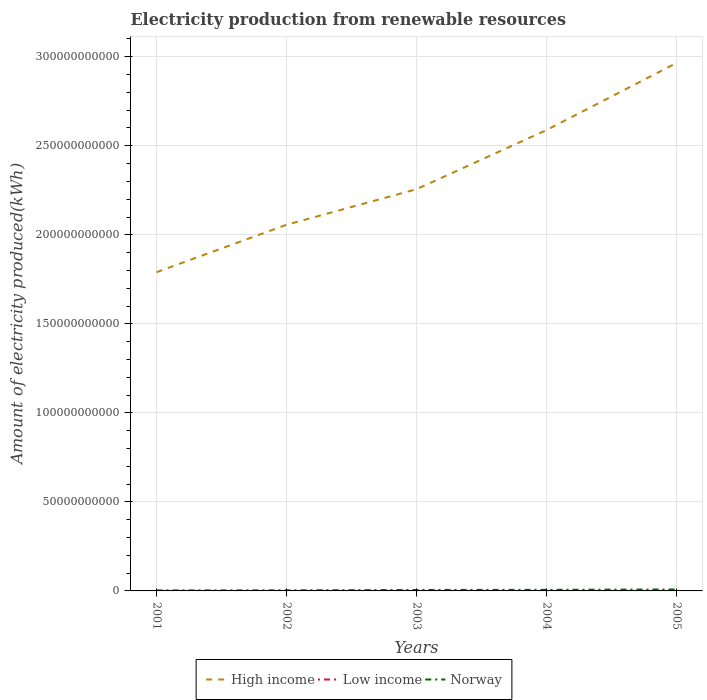Does the line corresponding to High income intersect with the line corresponding to Low income?
Make the answer very short. No. Is the number of lines equal to the number of legend labels?
Your answer should be very brief. Yes. Across all years, what is the maximum amount of electricity produced in Norway?
Provide a succinct answer. 2.82e+08. What is the total amount of electricity produced in High income in the graph?
Keep it short and to the point. -3.32e+1. What is the difference between the highest and the second highest amount of electricity produced in High income?
Your response must be concise. 1.17e+11. What is the difference between the highest and the lowest amount of electricity produced in Low income?
Offer a very short reply. 3. Is the amount of electricity produced in High income strictly greater than the amount of electricity produced in Norway over the years?
Your answer should be very brief. No. How many years are there in the graph?
Give a very brief answer. 5. Are the values on the major ticks of Y-axis written in scientific E-notation?
Provide a short and direct response. No. Does the graph contain any zero values?
Your answer should be very brief. No. How are the legend labels stacked?
Your answer should be very brief. Horizontal. What is the title of the graph?
Your answer should be very brief. Electricity production from renewable resources. What is the label or title of the Y-axis?
Your response must be concise. Amount of electricity produced(kWh). What is the Amount of electricity produced(kWh) of High income in 2001?
Give a very brief answer. 1.79e+11. What is the Amount of electricity produced(kWh) in Norway in 2001?
Keep it short and to the point. 2.82e+08. What is the Amount of electricity produced(kWh) in High income in 2002?
Offer a terse response. 2.06e+11. What is the Amount of electricity produced(kWh) of Low income in 2002?
Your answer should be very brief. 3.00e+06. What is the Amount of electricity produced(kWh) of Norway in 2002?
Provide a short and direct response. 3.25e+08. What is the Amount of electricity produced(kWh) of High income in 2003?
Keep it short and to the point. 2.26e+11. What is the Amount of electricity produced(kWh) of Low income in 2003?
Offer a terse response. 1.10e+07. What is the Amount of electricity produced(kWh) of Norway in 2003?
Provide a short and direct response. 5.48e+08. What is the Amount of electricity produced(kWh) of High income in 2004?
Offer a terse response. 2.59e+11. What is the Amount of electricity produced(kWh) in Low income in 2004?
Offer a very short reply. 1.70e+07. What is the Amount of electricity produced(kWh) in Norway in 2004?
Provide a short and direct response. 6.11e+08. What is the Amount of electricity produced(kWh) of High income in 2005?
Offer a very short reply. 2.97e+11. What is the Amount of electricity produced(kWh) of Low income in 2005?
Your response must be concise. 1.80e+07. What is the Amount of electricity produced(kWh) in Norway in 2005?
Give a very brief answer. 8.32e+08. Across all years, what is the maximum Amount of electricity produced(kWh) in High income?
Make the answer very short. 2.97e+11. Across all years, what is the maximum Amount of electricity produced(kWh) of Low income?
Offer a very short reply. 1.80e+07. Across all years, what is the maximum Amount of electricity produced(kWh) of Norway?
Provide a short and direct response. 8.32e+08. Across all years, what is the minimum Amount of electricity produced(kWh) of High income?
Provide a succinct answer. 1.79e+11. Across all years, what is the minimum Amount of electricity produced(kWh) of Low income?
Offer a terse response. 3.00e+06. Across all years, what is the minimum Amount of electricity produced(kWh) in Norway?
Provide a succinct answer. 2.82e+08. What is the total Amount of electricity produced(kWh) of High income in the graph?
Ensure brevity in your answer.  1.17e+12. What is the total Amount of electricity produced(kWh) of Low income in the graph?
Provide a succinct answer. 5.30e+07. What is the total Amount of electricity produced(kWh) of Norway in the graph?
Provide a succinct answer. 2.60e+09. What is the difference between the Amount of electricity produced(kWh) in High income in 2001 and that in 2002?
Offer a very short reply. -2.66e+1. What is the difference between the Amount of electricity produced(kWh) in Low income in 2001 and that in 2002?
Make the answer very short. 1.00e+06. What is the difference between the Amount of electricity produced(kWh) of Norway in 2001 and that in 2002?
Ensure brevity in your answer.  -4.30e+07. What is the difference between the Amount of electricity produced(kWh) in High income in 2001 and that in 2003?
Keep it short and to the point. -4.66e+1. What is the difference between the Amount of electricity produced(kWh) of Low income in 2001 and that in 2003?
Make the answer very short. -7.00e+06. What is the difference between the Amount of electricity produced(kWh) in Norway in 2001 and that in 2003?
Your answer should be compact. -2.66e+08. What is the difference between the Amount of electricity produced(kWh) in High income in 2001 and that in 2004?
Give a very brief answer. -7.98e+1. What is the difference between the Amount of electricity produced(kWh) in Low income in 2001 and that in 2004?
Your answer should be compact. -1.30e+07. What is the difference between the Amount of electricity produced(kWh) in Norway in 2001 and that in 2004?
Give a very brief answer. -3.29e+08. What is the difference between the Amount of electricity produced(kWh) in High income in 2001 and that in 2005?
Offer a very short reply. -1.17e+11. What is the difference between the Amount of electricity produced(kWh) in Low income in 2001 and that in 2005?
Your answer should be very brief. -1.40e+07. What is the difference between the Amount of electricity produced(kWh) in Norway in 2001 and that in 2005?
Keep it short and to the point. -5.50e+08. What is the difference between the Amount of electricity produced(kWh) of High income in 2002 and that in 2003?
Your response must be concise. -2.00e+1. What is the difference between the Amount of electricity produced(kWh) in Low income in 2002 and that in 2003?
Your answer should be compact. -8.00e+06. What is the difference between the Amount of electricity produced(kWh) in Norway in 2002 and that in 2003?
Offer a terse response. -2.23e+08. What is the difference between the Amount of electricity produced(kWh) in High income in 2002 and that in 2004?
Your answer should be very brief. -5.32e+1. What is the difference between the Amount of electricity produced(kWh) in Low income in 2002 and that in 2004?
Keep it short and to the point. -1.40e+07. What is the difference between the Amount of electricity produced(kWh) of Norway in 2002 and that in 2004?
Make the answer very short. -2.86e+08. What is the difference between the Amount of electricity produced(kWh) in High income in 2002 and that in 2005?
Ensure brevity in your answer.  -9.09e+1. What is the difference between the Amount of electricity produced(kWh) in Low income in 2002 and that in 2005?
Your answer should be compact. -1.50e+07. What is the difference between the Amount of electricity produced(kWh) in Norway in 2002 and that in 2005?
Ensure brevity in your answer.  -5.07e+08. What is the difference between the Amount of electricity produced(kWh) in High income in 2003 and that in 2004?
Your answer should be compact. -3.32e+1. What is the difference between the Amount of electricity produced(kWh) in Low income in 2003 and that in 2004?
Your answer should be compact. -6.00e+06. What is the difference between the Amount of electricity produced(kWh) in Norway in 2003 and that in 2004?
Your answer should be compact. -6.30e+07. What is the difference between the Amount of electricity produced(kWh) of High income in 2003 and that in 2005?
Make the answer very short. -7.09e+1. What is the difference between the Amount of electricity produced(kWh) in Low income in 2003 and that in 2005?
Your answer should be compact. -7.00e+06. What is the difference between the Amount of electricity produced(kWh) of Norway in 2003 and that in 2005?
Make the answer very short. -2.84e+08. What is the difference between the Amount of electricity produced(kWh) in High income in 2004 and that in 2005?
Make the answer very short. -3.77e+1. What is the difference between the Amount of electricity produced(kWh) in Low income in 2004 and that in 2005?
Your response must be concise. -1.00e+06. What is the difference between the Amount of electricity produced(kWh) of Norway in 2004 and that in 2005?
Keep it short and to the point. -2.21e+08. What is the difference between the Amount of electricity produced(kWh) in High income in 2001 and the Amount of electricity produced(kWh) in Low income in 2002?
Your answer should be compact. 1.79e+11. What is the difference between the Amount of electricity produced(kWh) of High income in 2001 and the Amount of electricity produced(kWh) of Norway in 2002?
Your answer should be very brief. 1.79e+11. What is the difference between the Amount of electricity produced(kWh) in Low income in 2001 and the Amount of electricity produced(kWh) in Norway in 2002?
Provide a succinct answer. -3.21e+08. What is the difference between the Amount of electricity produced(kWh) of High income in 2001 and the Amount of electricity produced(kWh) of Low income in 2003?
Your response must be concise. 1.79e+11. What is the difference between the Amount of electricity produced(kWh) in High income in 2001 and the Amount of electricity produced(kWh) in Norway in 2003?
Give a very brief answer. 1.78e+11. What is the difference between the Amount of electricity produced(kWh) in Low income in 2001 and the Amount of electricity produced(kWh) in Norway in 2003?
Give a very brief answer. -5.44e+08. What is the difference between the Amount of electricity produced(kWh) in High income in 2001 and the Amount of electricity produced(kWh) in Low income in 2004?
Offer a terse response. 1.79e+11. What is the difference between the Amount of electricity produced(kWh) in High income in 2001 and the Amount of electricity produced(kWh) in Norway in 2004?
Offer a very short reply. 1.78e+11. What is the difference between the Amount of electricity produced(kWh) in Low income in 2001 and the Amount of electricity produced(kWh) in Norway in 2004?
Give a very brief answer. -6.07e+08. What is the difference between the Amount of electricity produced(kWh) of High income in 2001 and the Amount of electricity produced(kWh) of Low income in 2005?
Ensure brevity in your answer.  1.79e+11. What is the difference between the Amount of electricity produced(kWh) of High income in 2001 and the Amount of electricity produced(kWh) of Norway in 2005?
Your answer should be very brief. 1.78e+11. What is the difference between the Amount of electricity produced(kWh) in Low income in 2001 and the Amount of electricity produced(kWh) in Norway in 2005?
Offer a very short reply. -8.28e+08. What is the difference between the Amount of electricity produced(kWh) in High income in 2002 and the Amount of electricity produced(kWh) in Low income in 2003?
Provide a short and direct response. 2.06e+11. What is the difference between the Amount of electricity produced(kWh) in High income in 2002 and the Amount of electricity produced(kWh) in Norway in 2003?
Make the answer very short. 2.05e+11. What is the difference between the Amount of electricity produced(kWh) of Low income in 2002 and the Amount of electricity produced(kWh) of Norway in 2003?
Your answer should be very brief. -5.45e+08. What is the difference between the Amount of electricity produced(kWh) in High income in 2002 and the Amount of electricity produced(kWh) in Low income in 2004?
Your answer should be very brief. 2.06e+11. What is the difference between the Amount of electricity produced(kWh) in High income in 2002 and the Amount of electricity produced(kWh) in Norway in 2004?
Provide a succinct answer. 2.05e+11. What is the difference between the Amount of electricity produced(kWh) in Low income in 2002 and the Amount of electricity produced(kWh) in Norway in 2004?
Provide a succinct answer. -6.08e+08. What is the difference between the Amount of electricity produced(kWh) in High income in 2002 and the Amount of electricity produced(kWh) in Low income in 2005?
Your response must be concise. 2.06e+11. What is the difference between the Amount of electricity produced(kWh) in High income in 2002 and the Amount of electricity produced(kWh) in Norway in 2005?
Keep it short and to the point. 2.05e+11. What is the difference between the Amount of electricity produced(kWh) in Low income in 2002 and the Amount of electricity produced(kWh) in Norway in 2005?
Your answer should be very brief. -8.29e+08. What is the difference between the Amount of electricity produced(kWh) of High income in 2003 and the Amount of electricity produced(kWh) of Low income in 2004?
Provide a short and direct response. 2.26e+11. What is the difference between the Amount of electricity produced(kWh) in High income in 2003 and the Amount of electricity produced(kWh) in Norway in 2004?
Keep it short and to the point. 2.25e+11. What is the difference between the Amount of electricity produced(kWh) of Low income in 2003 and the Amount of electricity produced(kWh) of Norway in 2004?
Your response must be concise. -6.00e+08. What is the difference between the Amount of electricity produced(kWh) in High income in 2003 and the Amount of electricity produced(kWh) in Low income in 2005?
Provide a short and direct response. 2.26e+11. What is the difference between the Amount of electricity produced(kWh) of High income in 2003 and the Amount of electricity produced(kWh) of Norway in 2005?
Provide a short and direct response. 2.25e+11. What is the difference between the Amount of electricity produced(kWh) in Low income in 2003 and the Amount of electricity produced(kWh) in Norway in 2005?
Provide a succinct answer. -8.21e+08. What is the difference between the Amount of electricity produced(kWh) of High income in 2004 and the Amount of electricity produced(kWh) of Low income in 2005?
Your response must be concise. 2.59e+11. What is the difference between the Amount of electricity produced(kWh) in High income in 2004 and the Amount of electricity produced(kWh) in Norway in 2005?
Ensure brevity in your answer.  2.58e+11. What is the difference between the Amount of electricity produced(kWh) of Low income in 2004 and the Amount of electricity produced(kWh) of Norway in 2005?
Your response must be concise. -8.15e+08. What is the average Amount of electricity produced(kWh) in High income per year?
Keep it short and to the point. 2.33e+11. What is the average Amount of electricity produced(kWh) of Low income per year?
Your response must be concise. 1.06e+07. What is the average Amount of electricity produced(kWh) in Norway per year?
Provide a short and direct response. 5.20e+08. In the year 2001, what is the difference between the Amount of electricity produced(kWh) of High income and Amount of electricity produced(kWh) of Low income?
Make the answer very short. 1.79e+11. In the year 2001, what is the difference between the Amount of electricity produced(kWh) in High income and Amount of electricity produced(kWh) in Norway?
Provide a short and direct response. 1.79e+11. In the year 2001, what is the difference between the Amount of electricity produced(kWh) in Low income and Amount of electricity produced(kWh) in Norway?
Offer a very short reply. -2.78e+08. In the year 2002, what is the difference between the Amount of electricity produced(kWh) in High income and Amount of electricity produced(kWh) in Low income?
Offer a very short reply. 2.06e+11. In the year 2002, what is the difference between the Amount of electricity produced(kWh) in High income and Amount of electricity produced(kWh) in Norway?
Make the answer very short. 2.05e+11. In the year 2002, what is the difference between the Amount of electricity produced(kWh) of Low income and Amount of electricity produced(kWh) of Norway?
Your response must be concise. -3.22e+08. In the year 2003, what is the difference between the Amount of electricity produced(kWh) of High income and Amount of electricity produced(kWh) of Low income?
Offer a terse response. 2.26e+11. In the year 2003, what is the difference between the Amount of electricity produced(kWh) of High income and Amount of electricity produced(kWh) of Norway?
Provide a short and direct response. 2.25e+11. In the year 2003, what is the difference between the Amount of electricity produced(kWh) of Low income and Amount of electricity produced(kWh) of Norway?
Provide a succinct answer. -5.37e+08. In the year 2004, what is the difference between the Amount of electricity produced(kWh) in High income and Amount of electricity produced(kWh) in Low income?
Your response must be concise. 2.59e+11. In the year 2004, what is the difference between the Amount of electricity produced(kWh) in High income and Amount of electricity produced(kWh) in Norway?
Give a very brief answer. 2.58e+11. In the year 2004, what is the difference between the Amount of electricity produced(kWh) of Low income and Amount of electricity produced(kWh) of Norway?
Your answer should be compact. -5.94e+08. In the year 2005, what is the difference between the Amount of electricity produced(kWh) in High income and Amount of electricity produced(kWh) in Low income?
Your response must be concise. 2.96e+11. In the year 2005, what is the difference between the Amount of electricity produced(kWh) in High income and Amount of electricity produced(kWh) in Norway?
Give a very brief answer. 2.96e+11. In the year 2005, what is the difference between the Amount of electricity produced(kWh) in Low income and Amount of electricity produced(kWh) in Norway?
Your answer should be very brief. -8.14e+08. What is the ratio of the Amount of electricity produced(kWh) of High income in 2001 to that in 2002?
Make the answer very short. 0.87. What is the ratio of the Amount of electricity produced(kWh) in Norway in 2001 to that in 2002?
Provide a succinct answer. 0.87. What is the ratio of the Amount of electricity produced(kWh) of High income in 2001 to that in 2003?
Provide a short and direct response. 0.79. What is the ratio of the Amount of electricity produced(kWh) in Low income in 2001 to that in 2003?
Your response must be concise. 0.36. What is the ratio of the Amount of electricity produced(kWh) in Norway in 2001 to that in 2003?
Make the answer very short. 0.51. What is the ratio of the Amount of electricity produced(kWh) in High income in 2001 to that in 2004?
Offer a terse response. 0.69. What is the ratio of the Amount of electricity produced(kWh) in Low income in 2001 to that in 2004?
Ensure brevity in your answer.  0.24. What is the ratio of the Amount of electricity produced(kWh) of Norway in 2001 to that in 2004?
Offer a very short reply. 0.46. What is the ratio of the Amount of electricity produced(kWh) of High income in 2001 to that in 2005?
Your answer should be very brief. 0.6. What is the ratio of the Amount of electricity produced(kWh) of Low income in 2001 to that in 2005?
Offer a terse response. 0.22. What is the ratio of the Amount of electricity produced(kWh) of Norway in 2001 to that in 2005?
Your response must be concise. 0.34. What is the ratio of the Amount of electricity produced(kWh) in High income in 2002 to that in 2003?
Provide a succinct answer. 0.91. What is the ratio of the Amount of electricity produced(kWh) of Low income in 2002 to that in 2003?
Provide a succinct answer. 0.27. What is the ratio of the Amount of electricity produced(kWh) in Norway in 2002 to that in 2003?
Provide a succinct answer. 0.59. What is the ratio of the Amount of electricity produced(kWh) in High income in 2002 to that in 2004?
Your answer should be very brief. 0.79. What is the ratio of the Amount of electricity produced(kWh) in Low income in 2002 to that in 2004?
Provide a short and direct response. 0.18. What is the ratio of the Amount of electricity produced(kWh) of Norway in 2002 to that in 2004?
Provide a short and direct response. 0.53. What is the ratio of the Amount of electricity produced(kWh) in High income in 2002 to that in 2005?
Give a very brief answer. 0.69. What is the ratio of the Amount of electricity produced(kWh) in Norway in 2002 to that in 2005?
Offer a terse response. 0.39. What is the ratio of the Amount of electricity produced(kWh) of High income in 2003 to that in 2004?
Your answer should be compact. 0.87. What is the ratio of the Amount of electricity produced(kWh) in Low income in 2003 to that in 2004?
Make the answer very short. 0.65. What is the ratio of the Amount of electricity produced(kWh) of Norway in 2003 to that in 2004?
Offer a terse response. 0.9. What is the ratio of the Amount of electricity produced(kWh) of High income in 2003 to that in 2005?
Keep it short and to the point. 0.76. What is the ratio of the Amount of electricity produced(kWh) of Low income in 2003 to that in 2005?
Ensure brevity in your answer.  0.61. What is the ratio of the Amount of electricity produced(kWh) of Norway in 2003 to that in 2005?
Provide a short and direct response. 0.66. What is the ratio of the Amount of electricity produced(kWh) in High income in 2004 to that in 2005?
Offer a very short reply. 0.87. What is the ratio of the Amount of electricity produced(kWh) in Low income in 2004 to that in 2005?
Provide a short and direct response. 0.94. What is the ratio of the Amount of electricity produced(kWh) of Norway in 2004 to that in 2005?
Provide a succinct answer. 0.73. What is the difference between the highest and the second highest Amount of electricity produced(kWh) in High income?
Offer a terse response. 3.77e+1. What is the difference between the highest and the second highest Amount of electricity produced(kWh) in Norway?
Make the answer very short. 2.21e+08. What is the difference between the highest and the lowest Amount of electricity produced(kWh) of High income?
Your answer should be very brief. 1.17e+11. What is the difference between the highest and the lowest Amount of electricity produced(kWh) in Low income?
Keep it short and to the point. 1.50e+07. What is the difference between the highest and the lowest Amount of electricity produced(kWh) of Norway?
Give a very brief answer. 5.50e+08. 